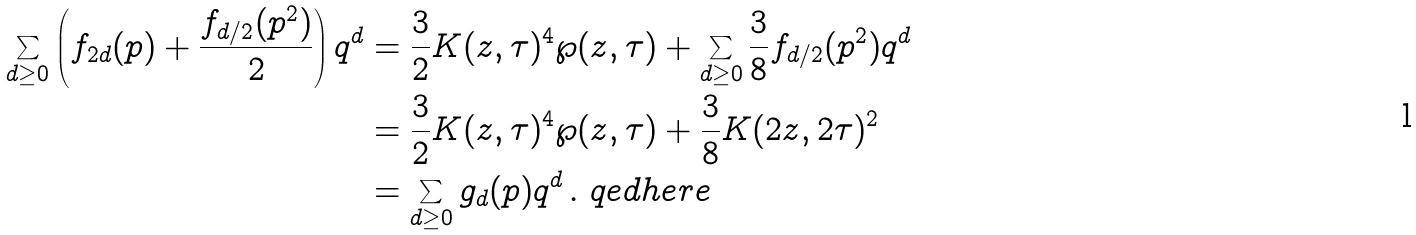<formula> <loc_0><loc_0><loc_500><loc_500>\sum _ { d \geq 0 } \left ( f _ { 2 d } ( p ) + \frac { f _ { d / 2 } ( p ^ { 2 } ) } { 2 } \right ) q ^ { d } & = \frac { 3 } { 2 } K ( z , \tau ) ^ { 4 } \wp ( z , \tau ) + \sum _ { d \geq 0 } \frac { 3 } { 8 } f _ { d / 2 } ( p ^ { 2 } ) q ^ { d } \\ & = \frac { 3 } { 2 } K ( z , \tau ) ^ { 4 } \wp ( z , \tau ) + \frac { 3 } { 8 } K ( 2 z , 2 \tau ) ^ { 2 } \\ & = \sum _ { d \geq 0 } g _ { d } ( p ) q ^ { d } \, . \ q e d h e r e</formula> 